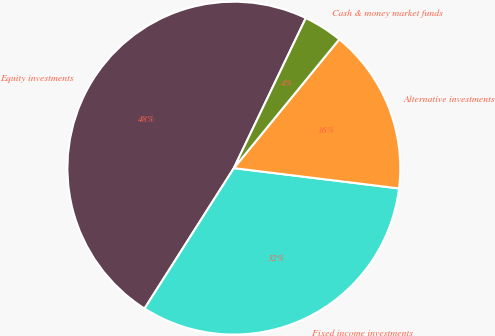<chart> <loc_0><loc_0><loc_500><loc_500><pie_chart><fcel>Equity investments<fcel>Fixed income investments<fcel>Alternative investments<fcel>Cash & money market funds<nl><fcel>48.1%<fcel>32.07%<fcel>16.03%<fcel>3.8%<nl></chart> 